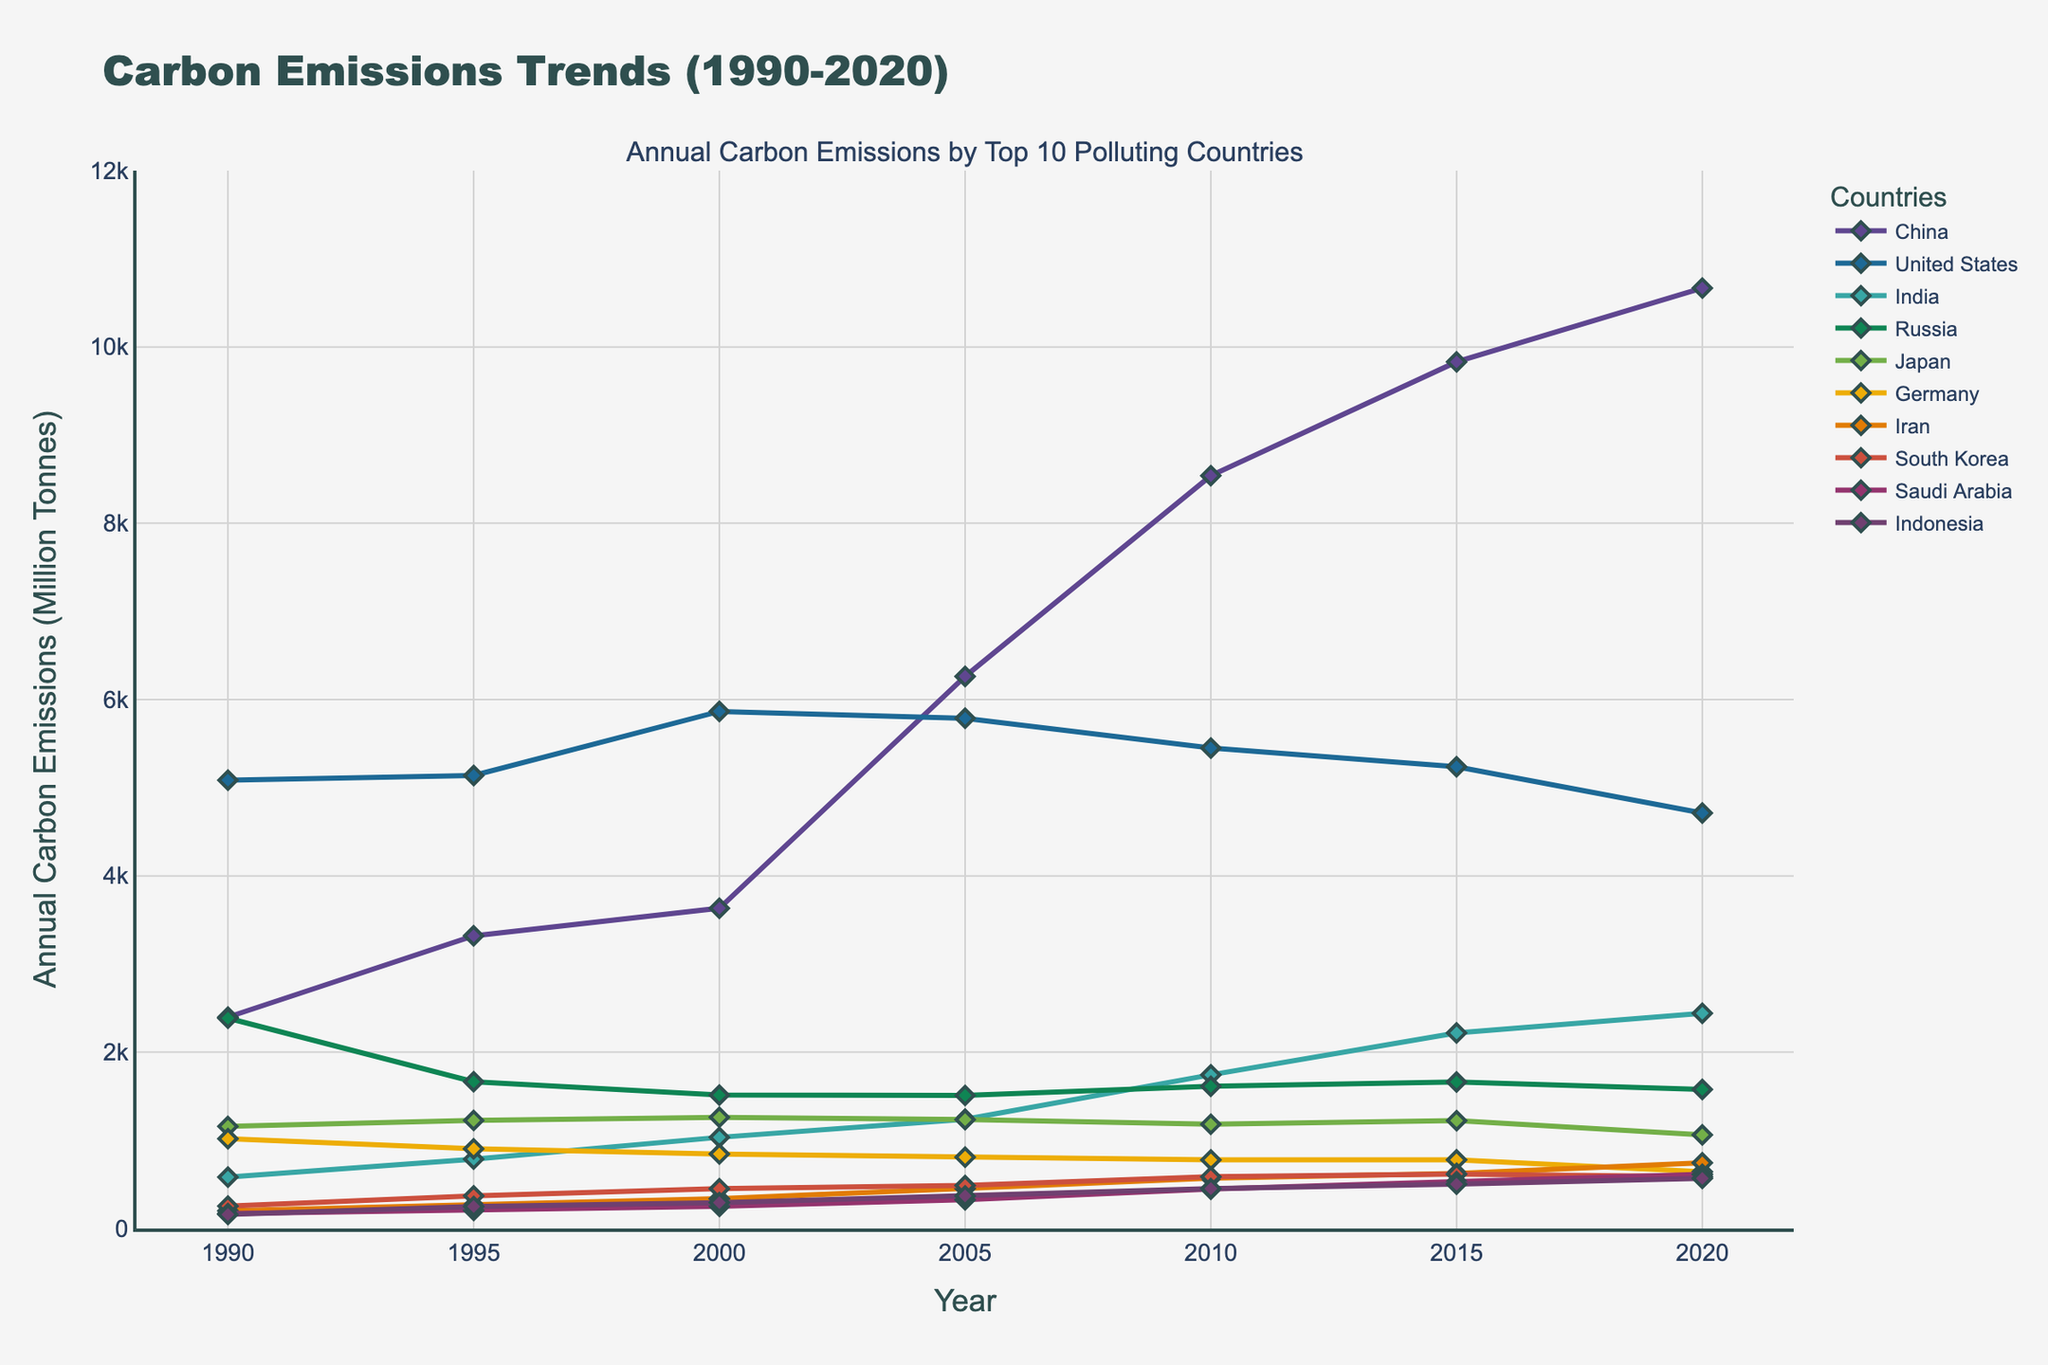Which country had the highest carbon emissions in 2020? Look at the line corresponding to 2020 and identify the country with the highest y-value.
Answer: China Between which years did India's carbon emissions have the steepest increase? Observe India's trend line and find the years with the most significant rise in the y-values. The steepest increase is between 2000 and 2005.
Answer: 2000-2005 How much did carbon emissions from the United States decrease from 2000 to 2020? Find the y-values for the United States in 2000 and 2020, then subtract the 2020 value from the 2000 value.
Answer: 1151.84 million tonnes Which country’s emissions remained relatively stable between 1990 and 2020? Look for a country whose trend line shows minimal changes in y-values through the years.
Answer: Germany What was the average carbon emission of Japan from 1990 to 2020? Sum the values of Japan's emissions across all the years and divide by the number of years (7). The total is (1158.01 + 1226.21 + 1261.45 + 1235.47 + 1182.49 + 1223.32 + 1061.77), which gives 8348.72. Then, 8348.72 / 7 = 1192.68
Answer: 1192.68 million tonnes Compare the emissions of China and the United States in 1995. Observe and compare the y-values of China and the United States for the year 1995. China has lower emissions than the United States in 1995.
Answer: The United States had higher emissions Which country had the lowest emissions in 1990? Identify the country with the smallest y-value for the year 1990.
Answer: Indonesia How do the emissions trends of South Korea and Saudi Arabia compare from 1990 to 2020? Observe the trend lines of both countries from 1990 to 2020 and compare their direction and steepness. Both countries show an increasing trend but Saudi Arabia's rise is more pronounced.
Answer: Saudi Arabia's emissions increased more steeply What is the total increase in carbon emissions for Iran from 1990 to 2020? Find the difference between Iran's emissions in 2020 and 1990 by subtracting the 1990 value from the 2020 value.
Answer: 543.75 million tonnes Which year did Germany experience the highest carbon emissions? Identify the peak y-value for Germany on the figure across all years and find the corresponding year.
Answer: 1990 